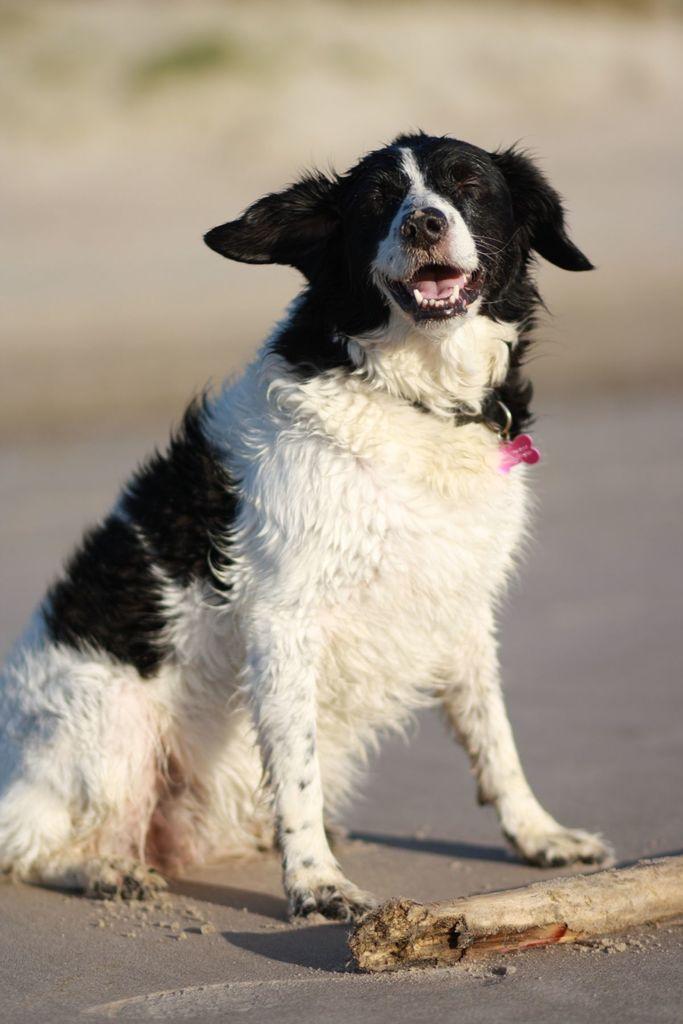Describe this image in one or two sentences. Background portion of the picture is blur. In this picture we can see a dog and a key-chain is visible. At the bottom portion of the picture we can see a wooden log on the road. 